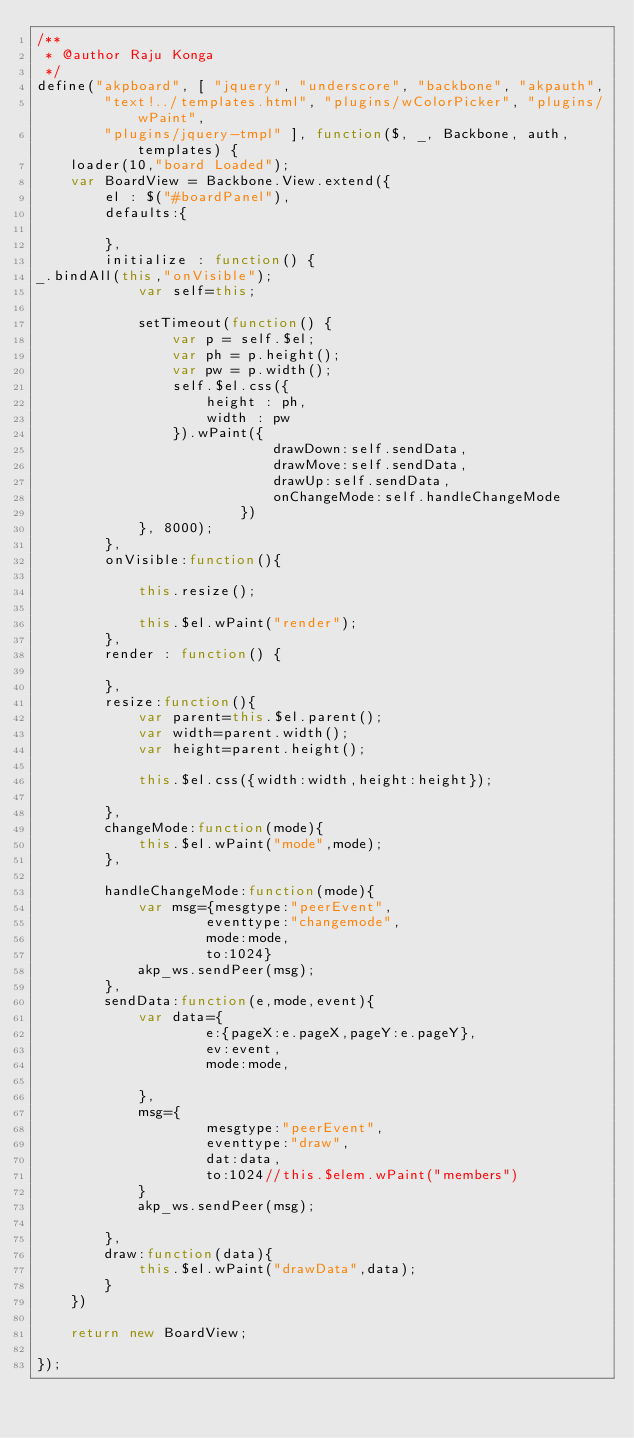<code> <loc_0><loc_0><loc_500><loc_500><_JavaScript_>/**
 * @author Raju Konga
 */
define("akpboard", [ "jquery", "underscore", "backbone", "akpauth",
		"text!../templates.html", "plugins/wColorPicker", "plugins/wPaint",
		"plugins/jquery-tmpl" ], function($, _, Backbone, auth, templates) {
	loader(10,"board Loaded");
	var BoardView = Backbone.View.extend({
		el : $("#boardPanel"),
		defaults:{
			
		},
		initialize : function() {
_.bindAll(this,"onVisible");
			var self=this;
			
			setTimeout(function() {
				var p = self.$el;
				var ph = p.height();
				var pw = p.width();
				self.$el.css({
					height : ph,
					width : pw
				}).wPaint({
							drawDown:self.sendData,
							drawMove:self.sendData,
							drawUp:self.sendData,
							onChangeMode:self.handleChangeMode
						})
			}, 8000);
		},
		onVisible:function(){
			
			this.resize();
			
			this.$el.wPaint("render");
		},
		render : function() {

		},
		resize:function(){
			var parent=this.$el.parent();
			var width=parent.width();
			var height=parent.height();
			
			this.$el.css({width:width,height:height});
			
		},
		changeMode:function(mode){
			this.$el.wPaint("mode",mode);
		},
		
		handleChangeMode:function(mode){
			var msg={mesgtype:"peerEvent",
					eventtype:"changemode",
					mode:mode,
					to:1024}
			akp_ws.sendPeer(msg);
		},
		sendData:function(e,mode,event){
			var data={
					e:{pageX:e.pageX,pageY:e.pageY},
					ev:event,
					mode:mode,
					
			},
			msg={
					mesgtype:"peerEvent",
					eventtype:"draw",
					dat:data,
					to:1024//this.$elem.wPaint("members")
			}
			akp_ws.sendPeer(msg);
			
		},
		draw:function(data){
			this.$el.wPaint("drawData",data);
		}
	})

	return new BoardView;

});
</code> 